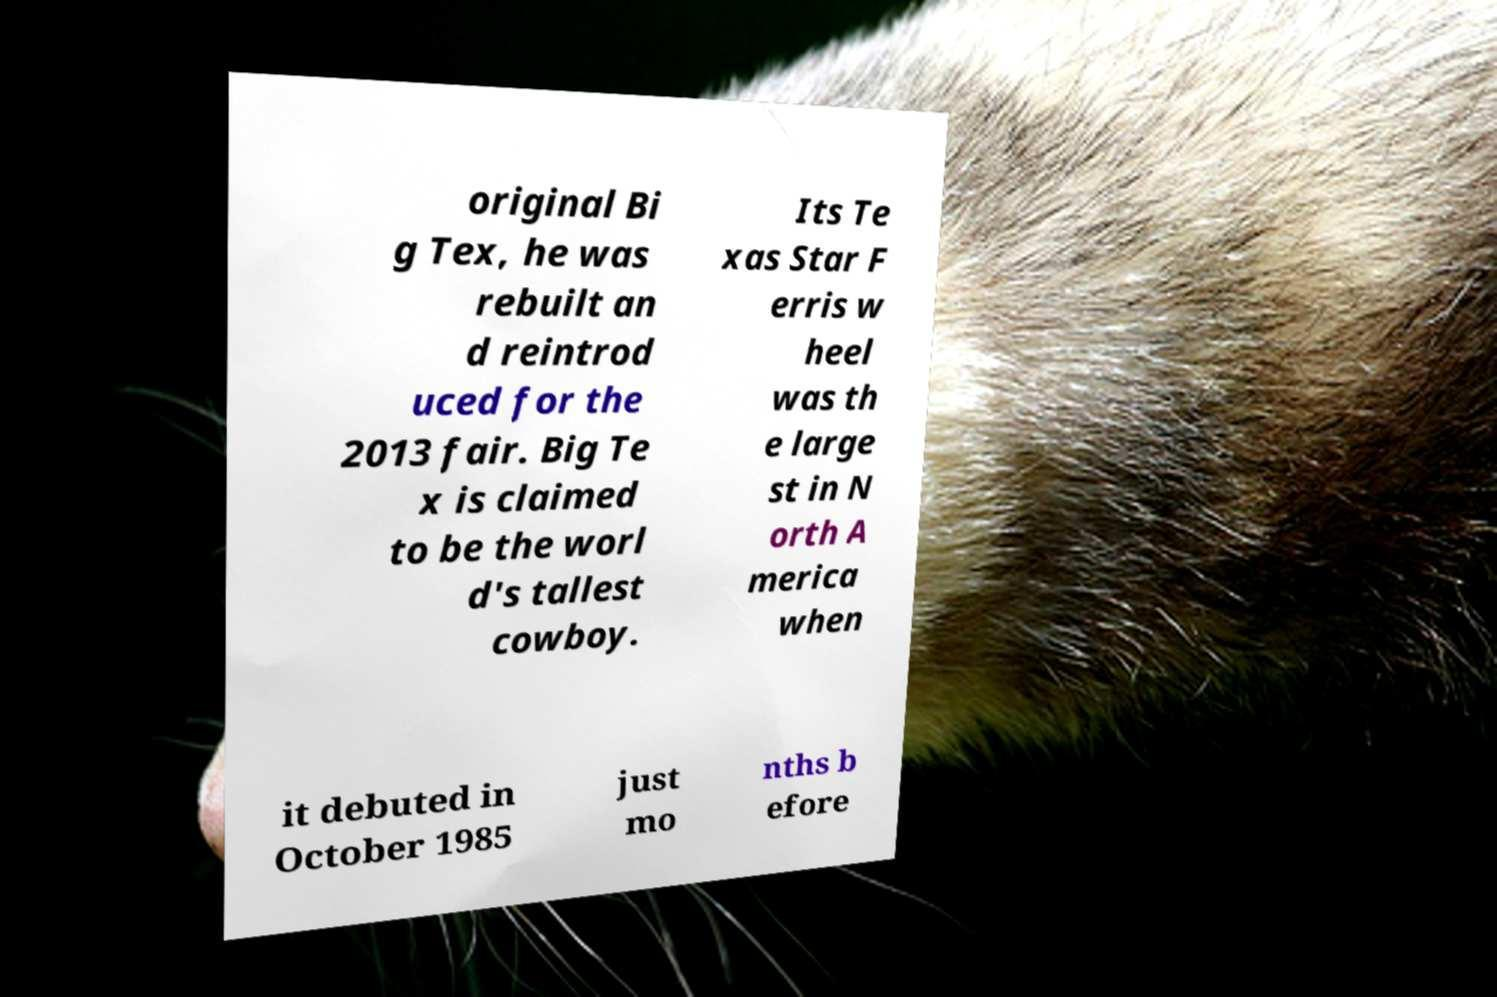Could you assist in decoding the text presented in this image and type it out clearly? original Bi g Tex, he was rebuilt an d reintrod uced for the 2013 fair. Big Te x is claimed to be the worl d's tallest cowboy. Its Te xas Star F erris w heel was th e large st in N orth A merica when it debuted in October 1985 just mo nths b efore 